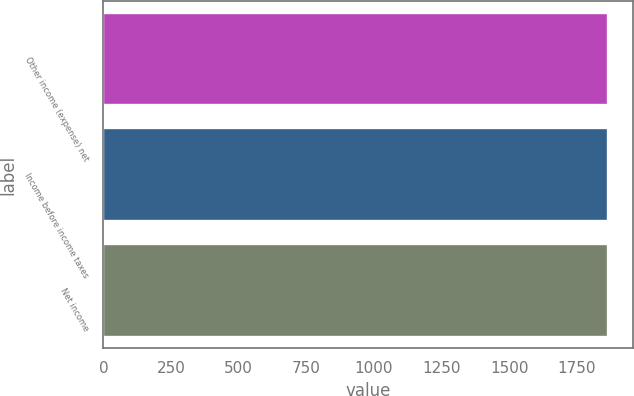<chart> <loc_0><loc_0><loc_500><loc_500><bar_chart><fcel>Other income (expense) net<fcel>Income before income taxes<fcel>Net income<nl><fcel>1864<fcel>1864.1<fcel>1864.2<nl></chart> 